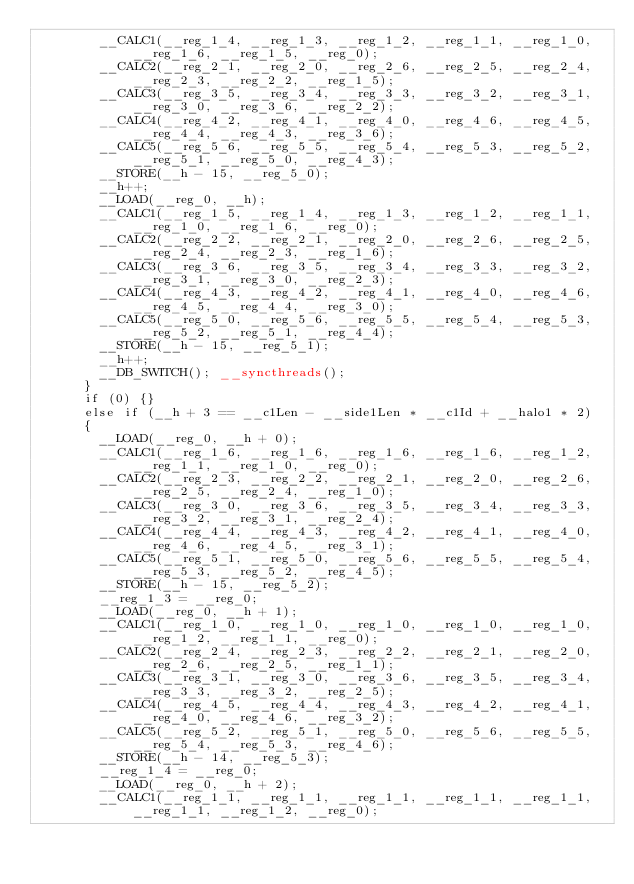Convert code to text. <code><loc_0><loc_0><loc_500><loc_500><_Cuda_>        __CALC1(__reg_1_4, __reg_1_3, __reg_1_2, __reg_1_1, __reg_1_0, __reg_1_6, __reg_1_5, __reg_0);
        __CALC2(__reg_2_1, __reg_2_0, __reg_2_6, __reg_2_5, __reg_2_4, __reg_2_3, __reg_2_2, __reg_1_5);
        __CALC3(__reg_3_5, __reg_3_4, __reg_3_3, __reg_3_2, __reg_3_1, __reg_3_0, __reg_3_6, __reg_2_2);
        __CALC4(__reg_4_2, __reg_4_1, __reg_4_0, __reg_4_6, __reg_4_5, __reg_4_4, __reg_4_3, __reg_3_6);
        __CALC5(__reg_5_6, __reg_5_5, __reg_5_4, __reg_5_3, __reg_5_2, __reg_5_1, __reg_5_0, __reg_4_3);
        __STORE(__h - 15, __reg_5_0);
        __h++;
        __LOAD(__reg_0, __h);
        __CALC1(__reg_1_5, __reg_1_4, __reg_1_3, __reg_1_2, __reg_1_1, __reg_1_0, __reg_1_6, __reg_0);
        __CALC2(__reg_2_2, __reg_2_1, __reg_2_0, __reg_2_6, __reg_2_5, __reg_2_4, __reg_2_3, __reg_1_6);
        __CALC3(__reg_3_6, __reg_3_5, __reg_3_4, __reg_3_3, __reg_3_2, __reg_3_1, __reg_3_0, __reg_2_3);
        __CALC4(__reg_4_3, __reg_4_2, __reg_4_1, __reg_4_0, __reg_4_6, __reg_4_5, __reg_4_4, __reg_3_0);
        __CALC5(__reg_5_0, __reg_5_6, __reg_5_5, __reg_5_4, __reg_5_3, __reg_5_2, __reg_5_1, __reg_4_4);
        __STORE(__h - 15, __reg_5_1);
        __h++;
        __DB_SWITCH(); __syncthreads();
      }
      if (0) {}
      else if (__h + 3 == __c1Len - __side1Len * __c1Id + __halo1 * 2)
      {
        __LOAD(__reg_0, __h + 0);
        __CALC1(__reg_1_6, __reg_1_6, __reg_1_6, __reg_1_6, __reg_1_2, __reg_1_1, __reg_1_0, __reg_0);
        __CALC2(__reg_2_3, __reg_2_2, __reg_2_1, __reg_2_0, __reg_2_6, __reg_2_5, __reg_2_4, __reg_1_0);
        __CALC3(__reg_3_0, __reg_3_6, __reg_3_5, __reg_3_4, __reg_3_3, __reg_3_2, __reg_3_1, __reg_2_4);
        __CALC4(__reg_4_4, __reg_4_3, __reg_4_2, __reg_4_1, __reg_4_0, __reg_4_6, __reg_4_5, __reg_3_1);
        __CALC5(__reg_5_1, __reg_5_0, __reg_5_6, __reg_5_5, __reg_5_4, __reg_5_3, __reg_5_2, __reg_4_5);
        __STORE(__h - 15, __reg_5_2);
        __reg_1_3 = __reg_0;
        __LOAD(__reg_0, __h + 1);
        __CALC1(__reg_1_0, __reg_1_0, __reg_1_0, __reg_1_0, __reg_1_0, __reg_1_2, __reg_1_1, __reg_0);
        __CALC2(__reg_2_4, __reg_2_3, __reg_2_2, __reg_2_1, __reg_2_0, __reg_2_6, __reg_2_5, __reg_1_1);
        __CALC3(__reg_3_1, __reg_3_0, __reg_3_6, __reg_3_5, __reg_3_4, __reg_3_3, __reg_3_2, __reg_2_5);
        __CALC4(__reg_4_5, __reg_4_4, __reg_4_3, __reg_4_2, __reg_4_1, __reg_4_0, __reg_4_6, __reg_3_2);
        __CALC5(__reg_5_2, __reg_5_1, __reg_5_0, __reg_5_6, __reg_5_5, __reg_5_4, __reg_5_3, __reg_4_6);
        __STORE(__h - 14, __reg_5_3);
        __reg_1_4 = __reg_0;
        __LOAD(__reg_0, __h + 2);
        __CALC1(__reg_1_1, __reg_1_1, __reg_1_1, __reg_1_1, __reg_1_1, __reg_1_1, __reg_1_2, __reg_0);</code> 